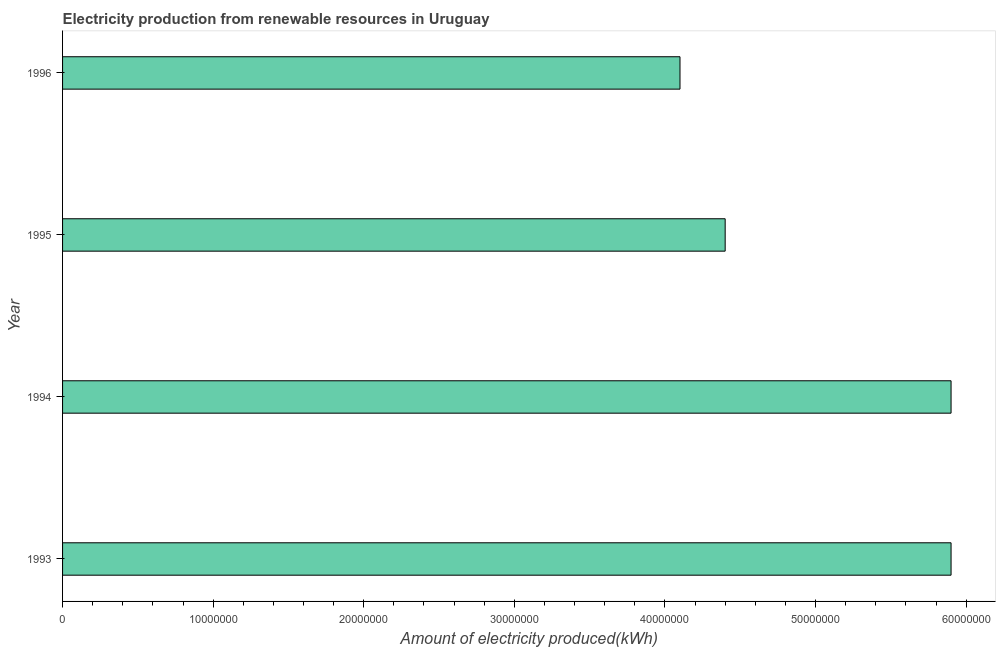Does the graph contain any zero values?
Make the answer very short. No. Does the graph contain grids?
Your answer should be compact. No. What is the title of the graph?
Your answer should be very brief. Electricity production from renewable resources in Uruguay. What is the label or title of the X-axis?
Offer a very short reply. Amount of electricity produced(kWh). What is the amount of electricity produced in 1996?
Give a very brief answer. 4.10e+07. Across all years, what is the maximum amount of electricity produced?
Your response must be concise. 5.90e+07. Across all years, what is the minimum amount of electricity produced?
Offer a terse response. 4.10e+07. In which year was the amount of electricity produced minimum?
Offer a very short reply. 1996. What is the sum of the amount of electricity produced?
Ensure brevity in your answer.  2.03e+08. What is the difference between the amount of electricity produced in 1993 and 1996?
Make the answer very short. 1.80e+07. What is the average amount of electricity produced per year?
Provide a short and direct response. 5.08e+07. What is the median amount of electricity produced?
Your answer should be compact. 5.15e+07. What is the ratio of the amount of electricity produced in 1993 to that in 1996?
Offer a terse response. 1.44. Is the difference between the amount of electricity produced in 1993 and 1995 greater than the difference between any two years?
Make the answer very short. No. Is the sum of the amount of electricity produced in 1993 and 1995 greater than the maximum amount of electricity produced across all years?
Your answer should be compact. Yes. What is the difference between the highest and the lowest amount of electricity produced?
Your response must be concise. 1.80e+07. In how many years, is the amount of electricity produced greater than the average amount of electricity produced taken over all years?
Offer a terse response. 2. How many bars are there?
Give a very brief answer. 4. Are all the bars in the graph horizontal?
Provide a short and direct response. Yes. What is the difference between two consecutive major ticks on the X-axis?
Your response must be concise. 1.00e+07. What is the Amount of electricity produced(kWh) of 1993?
Make the answer very short. 5.90e+07. What is the Amount of electricity produced(kWh) in 1994?
Make the answer very short. 5.90e+07. What is the Amount of electricity produced(kWh) of 1995?
Give a very brief answer. 4.40e+07. What is the Amount of electricity produced(kWh) of 1996?
Your response must be concise. 4.10e+07. What is the difference between the Amount of electricity produced(kWh) in 1993 and 1995?
Your response must be concise. 1.50e+07. What is the difference between the Amount of electricity produced(kWh) in 1993 and 1996?
Provide a short and direct response. 1.80e+07. What is the difference between the Amount of electricity produced(kWh) in 1994 and 1995?
Provide a succinct answer. 1.50e+07. What is the difference between the Amount of electricity produced(kWh) in 1994 and 1996?
Offer a terse response. 1.80e+07. What is the ratio of the Amount of electricity produced(kWh) in 1993 to that in 1994?
Ensure brevity in your answer.  1. What is the ratio of the Amount of electricity produced(kWh) in 1993 to that in 1995?
Ensure brevity in your answer.  1.34. What is the ratio of the Amount of electricity produced(kWh) in 1993 to that in 1996?
Provide a short and direct response. 1.44. What is the ratio of the Amount of electricity produced(kWh) in 1994 to that in 1995?
Keep it short and to the point. 1.34. What is the ratio of the Amount of electricity produced(kWh) in 1994 to that in 1996?
Keep it short and to the point. 1.44. What is the ratio of the Amount of electricity produced(kWh) in 1995 to that in 1996?
Keep it short and to the point. 1.07. 